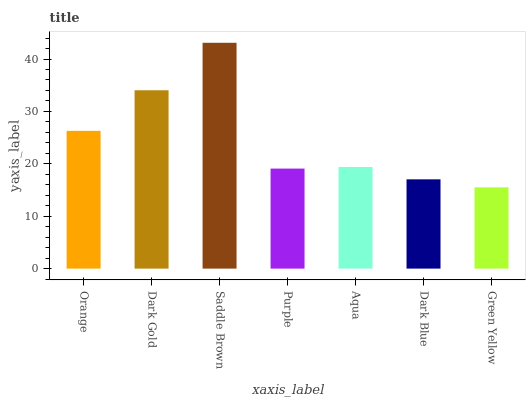Is Green Yellow the minimum?
Answer yes or no. Yes. Is Saddle Brown the maximum?
Answer yes or no. Yes. Is Dark Gold the minimum?
Answer yes or no. No. Is Dark Gold the maximum?
Answer yes or no. No. Is Dark Gold greater than Orange?
Answer yes or no. Yes. Is Orange less than Dark Gold?
Answer yes or no. Yes. Is Orange greater than Dark Gold?
Answer yes or no. No. Is Dark Gold less than Orange?
Answer yes or no. No. Is Aqua the high median?
Answer yes or no. Yes. Is Aqua the low median?
Answer yes or no. Yes. Is Purple the high median?
Answer yes or no. No. Is Green Yellow the low median?
Answer yes or no. No. 